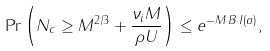Convert formula to latex. <formula><loc_0><loc_0><loc_500><loc_500>\Pr \left ( N _ { c } \geq M ^ { 2 / 3 } + \frac { \nu _ { i } M } { \rho U } \right ) \leq e ^ { - M \, B \cdot I ( a ) } ,</formula> 